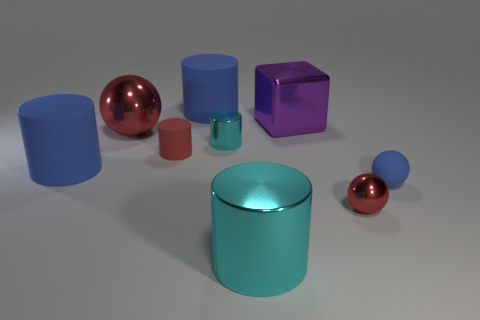Subtract all red cylinders. How many cylinders are left? 4 Subtract all big cyan shiny cylinders. How many cylinders are left? 4 Subtract all purple cylinders. Subtract all green blocks. How many cylinders are left? 5 Add 1 red shiny cubes. How many objects exist? 10 Subtract all balls. How many objects are left? 6 Subtract 0 green cylinders. How many objects are left? 9 Subtract all blue spheres. Subtract all small red spheres. How many objects are left? 7 Add 9 big purple shiny blocks. How many big purple shiny blocks are left? 10 Add 5 purple balls. How many purple balls exist? 5 